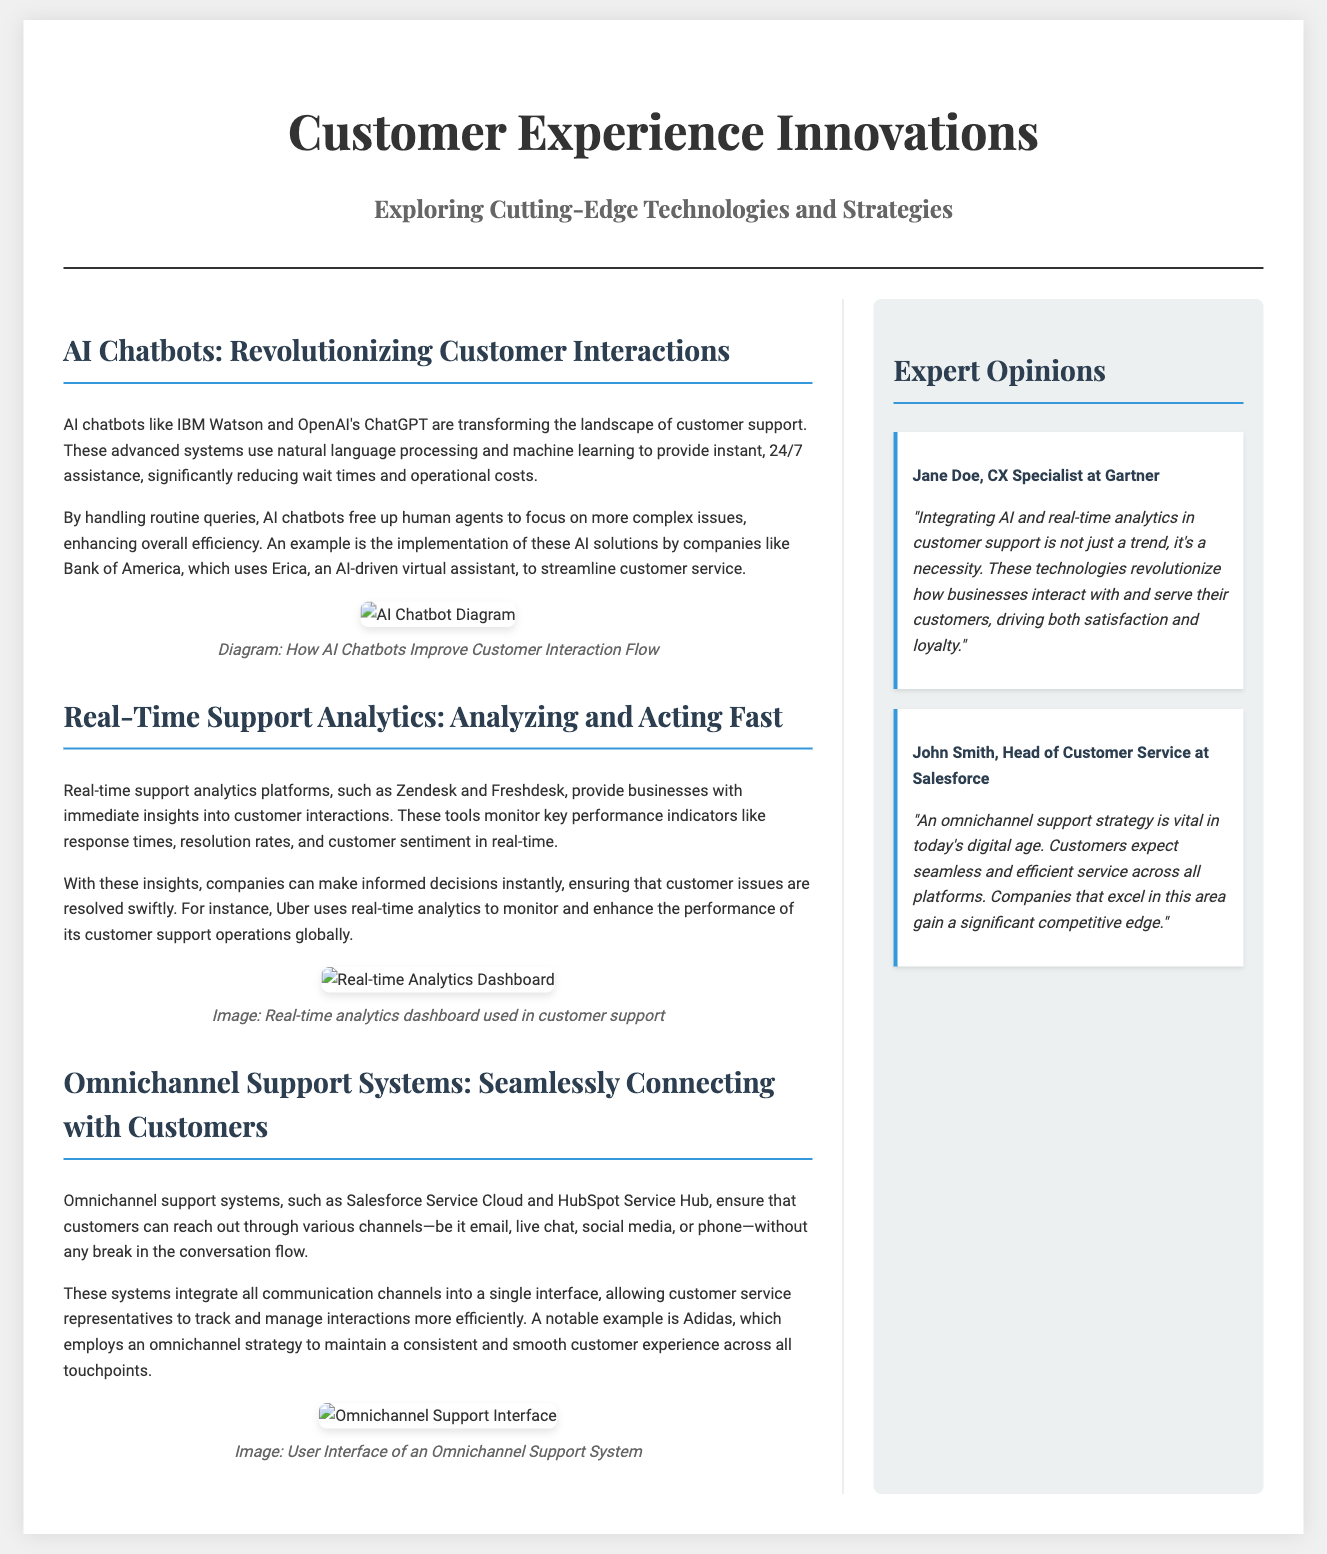What are AI chatbots transforming? AI chatbots are transforming the landscape of customer support.
Answer: customer support Which AI chatbot does Bank of America use? Bank of America uses Erica, an AI-driven virtual assistant.
Answer: Erica What platforms provide real-time support analytics? Platforms like Zendesk and Freshdesk provide real-time support analytics.
Answer: Zendesk and Freshdesk What does Uber use to enhance performance? Uber uses real-time analytics to monitor and enhance the performance of its customer support operations.
Answer: real-time analytics What is vital for today’s digital age according to John Smith? John Smith states that an omnichannel support strategy is vital in today’s digital age.
Answer: omnichannel support strategy Why are AI and real-time analytics considered a necessity? Integrating AI and real-time analytics is considered a necessity because they revolutionize how businesses interact with customers.
Answer: revolutionize interactions What is the primary focus of the document? The primary focus of the document is on customer experience innovations regarding support technologies and strategies.
Answer: customer experience innovations What is the color of the sidebar background? The sidebar background is a light gray shade known as #ecf0f1.
Answer: light gray Which company employs an omnichannel strategy? Adidas employs an omnichannel strategy to maintain consistent customer experience.
Answer: Adidas 